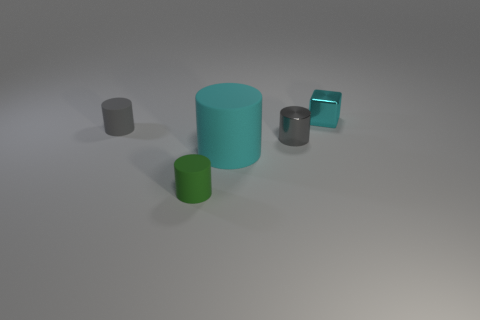Subtract all green cylinders. How many cylinders are left? 3 Subtract all large cylinders. How many cylinders are left? 3 Add 2 small green rubber balls. How many objects exist? 7 Subtract all blue cubes. Subtract all gray spheres. How many cubes are left? 1 Subtract all blocks. How many objects are left? 4 Add 1 small green things. How many small green things are left? 2 Add 1 large things. How many large things exist? 2 Subtract 1 cyan cubes. How many objects are left? 4 Subtract all gray shiny things. Subtract all shiny cylinders. How many objects are left? 3 